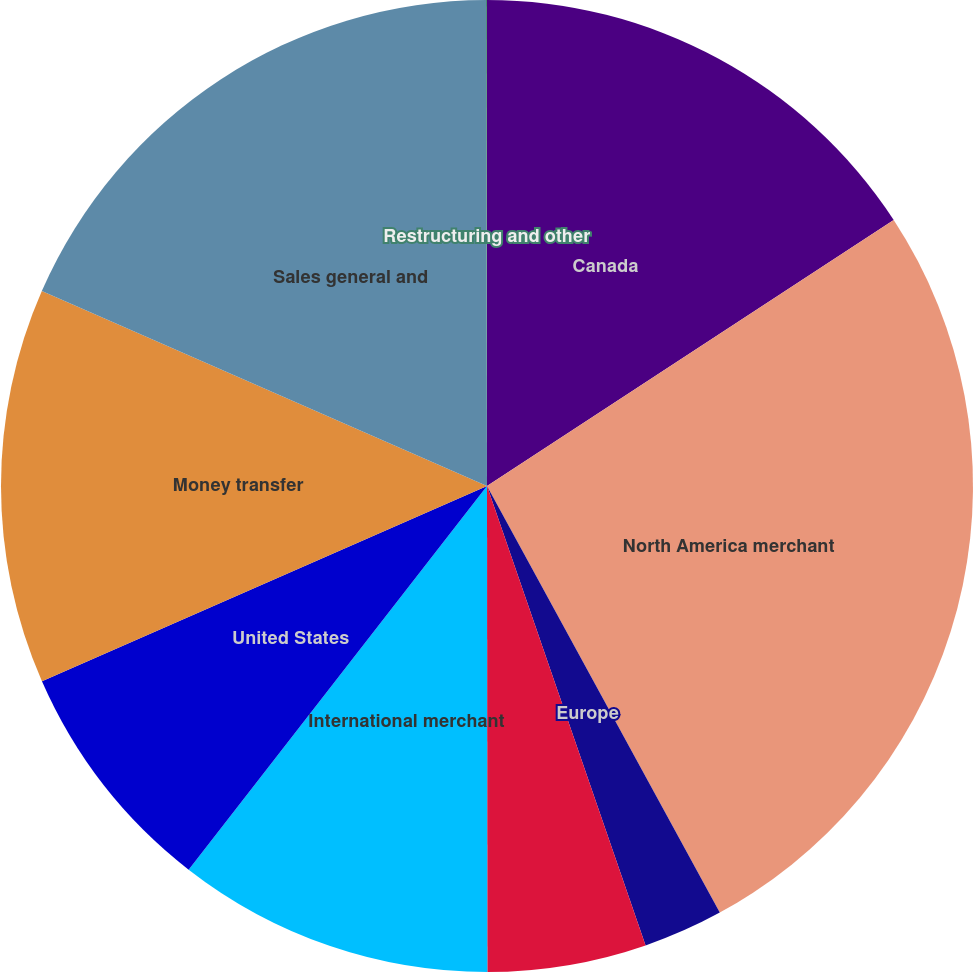Convert chart. <chart><loc_0><loc_0><loc_500><loc_500><pie_chart><fcel>Canada<fcel>North America merchant<fcel>Europe<fcel>Asia-Pacific<fcel>International merchant<fcel>United States<fcel>Money transfer<fcel>Sales general and<fcel>Restructuring and other<nl><fcel>15.78%<fcel>26.27%<fcel>2.66%<fcel>5.28%<fcel>10.53%<fcel>7.9%<fcel>13.15%<fcel>18.4%<fcel>0.03%<nl></chart> 